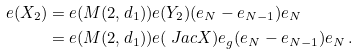Convert formula to latex. <formula><loc_0><loc_0><loc_500><loc_500>e ( X _ { 2 } ) = & \ e ( M ( 2 , d _ { 1 } ) ) e ( Y _ { 2 } ) ( e _ { N } - e _ { N - 1 } ) e _ { N } \\ = & \ e ( M ( 2 , d _ { 1 } ) ) e ( \ J a c X ) e _ { g } ( e _ { N } - e _ { N - 1 } ) e _ { N } \, .</formula> 